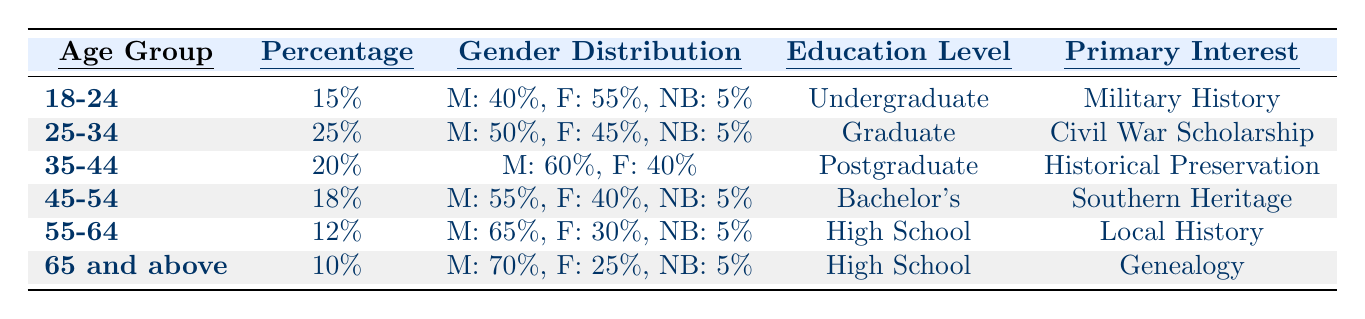What is the percentage of visitors in the age group of 25-34? The table indicates that the percentage of visitors aged 25-34 is explicitly listed next to that age group, which is 25%.
Answer: 25% Which age group has the highest percentage of visitors? Looking at the percentage values, the age group 25-34 has the highest percentage at 25%, which is higher than all other age groups.
Answer: 25-34 What are the primary interests of visitors aged 55-64? The table shows that the primary interest for the age group 55-64 is Local History, as stated in that row.
Answer: Local History Is there a higher percentage of male visitors in the 35-44 age group than in the 45-54 age group? The gender distribution shows that 60% of the 35-44 age group are male, while the 45-54 age group has 55% males, confirming that the 35-44 age group has a higher percentage of male visitors.
Answer: Yes What is the total percentage of visitors aged 18-24 and 25-34 combined? Adding the percentages for both age groups: 15% (for 18-24) + 25% (for 25-34) equals 40%.
Answer: 40% What is the difference in the male visitor percentage between the 65 and above age group and the 55-64 age group? The male percentage for 65 and above is 70%, while for 55-64, it is 65%. The difference is calculated as 70% - 65% = 5%.
Answer: 5% What percentage of visitors aged 45-54 identify as non-binary? The data indicates that 5% of visitors in the 45-54 age group identify as non-binary, as noted in that group's gender distribution.
Answer: 5% Considering the education levels, which age group has the highest education level? The age group 35-44 has the highest education level noted as Postgraduate, while other age groups have lower qualifications like Undergraduate or Graduate.
Answer: 35-44 What is the average percentage of visitors across all age groups? The percentages are 15%, 25%, 20%, 18%, 12%, and 10%. To find the average, sum these percentages (15 + 25 + 20 + 18 + 12 + 10 = 110) and divide by the number of groups (6), which results in approximately 18.33%.
Answer: 18.33% 